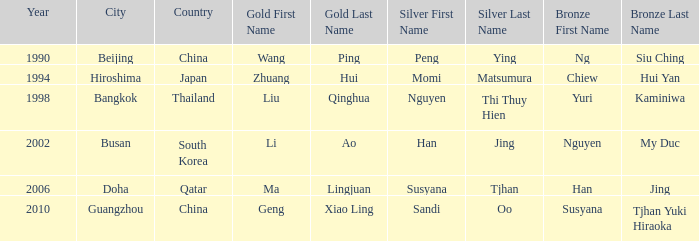What Gold has the Year of 1994? Zhuang Hui. 